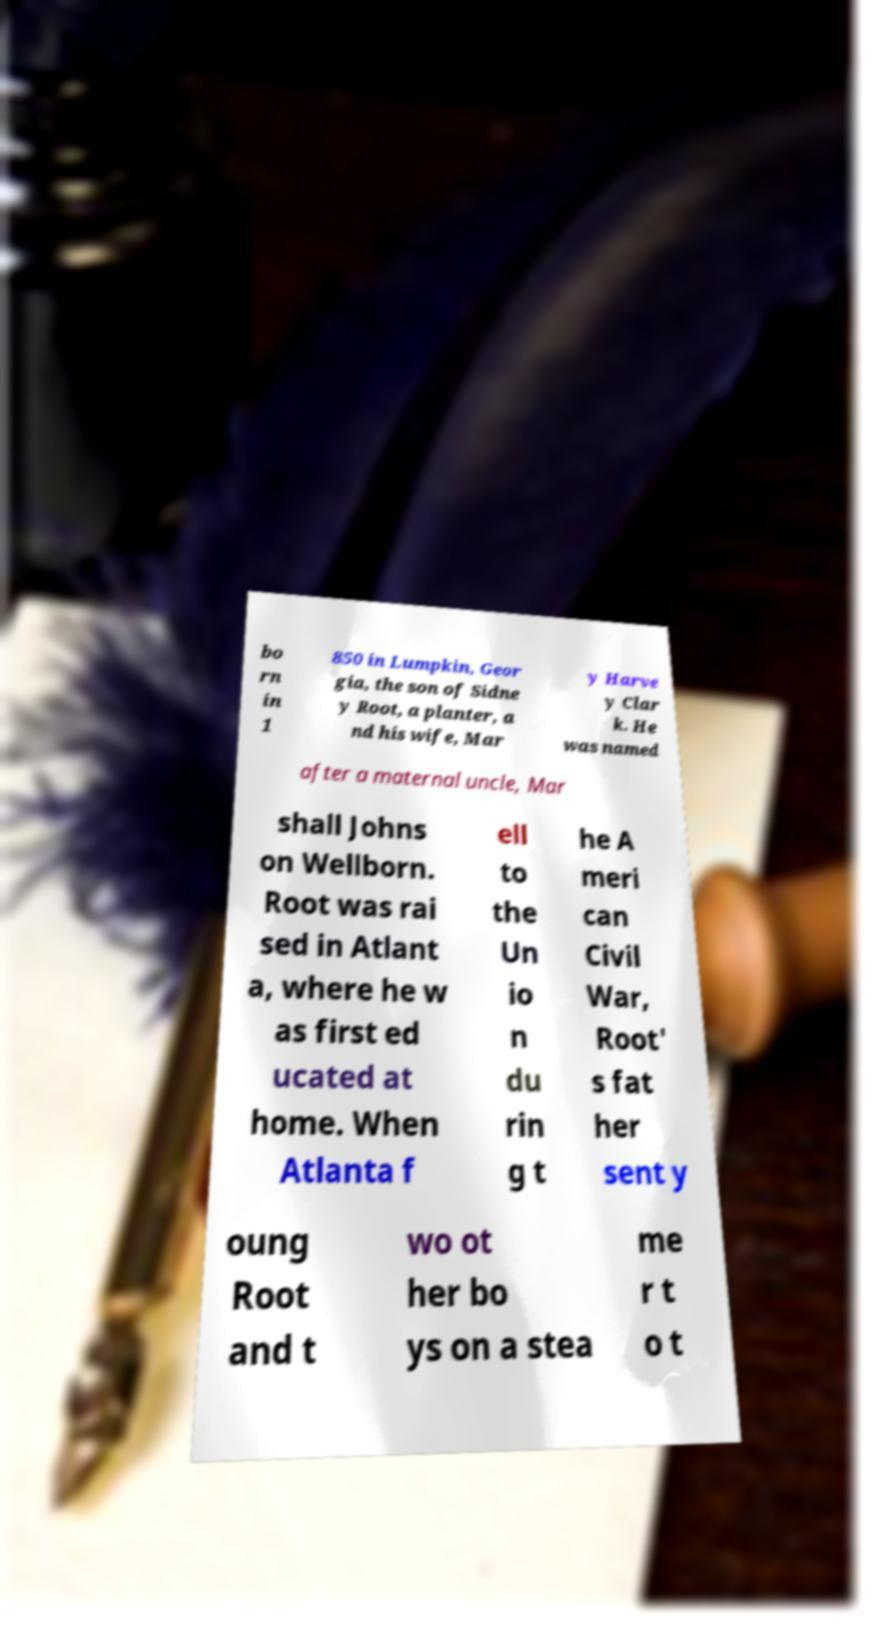Can you accurately transcribe the text from the provided image for me? bo rn in 1 850 in Lumpkin, Geor gia, the son of Sidne y Root, a planter, a nd his wife, Mar y Harve y Clar k. He was named after a maternal uncle, Mar shall Johns on Wellborn. Root was rai sed in Atlant a, where he w as first ed ucated at home. When Atlanta f ell to the Un io n du rin g t he A meri can Civil War, Root' s fat her sent y oung Root and t wo ot her bo ys on a stea me r t o t 